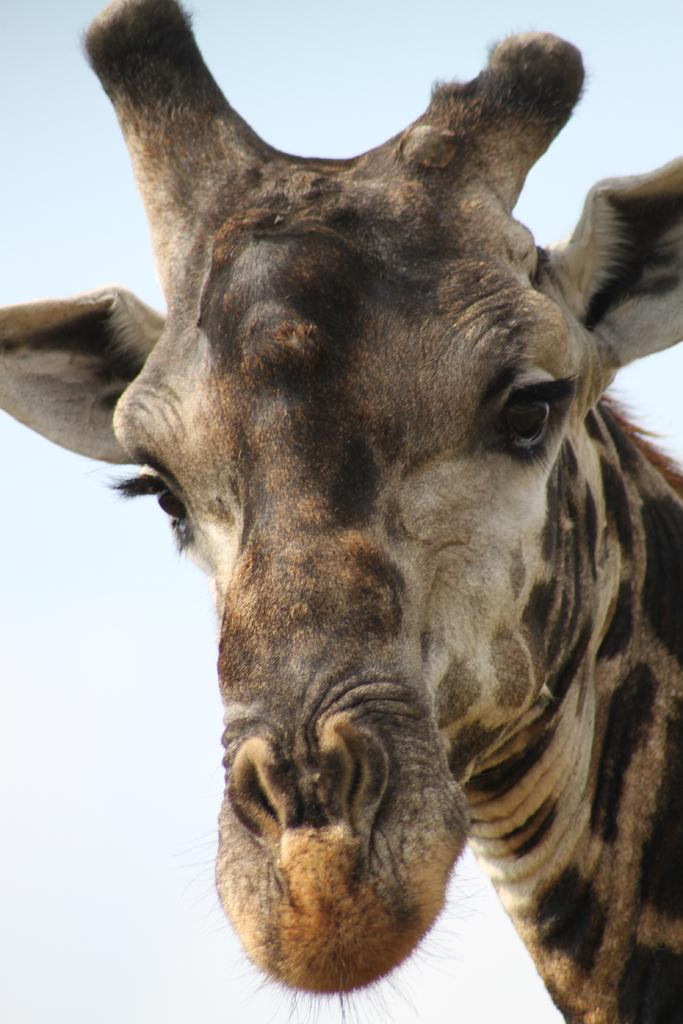What animal is the main subject of the image? There is a giraffe in the image. What part of the giraffe can be seen in the image? The face of the giraffe is visible. What is the color of the background in the image? The background of the image is white in color. What scent can be detected from the giraffe in the image? There is no information about the scent of the giraffe in the image, as it is a visual representation and not a sensory one. 